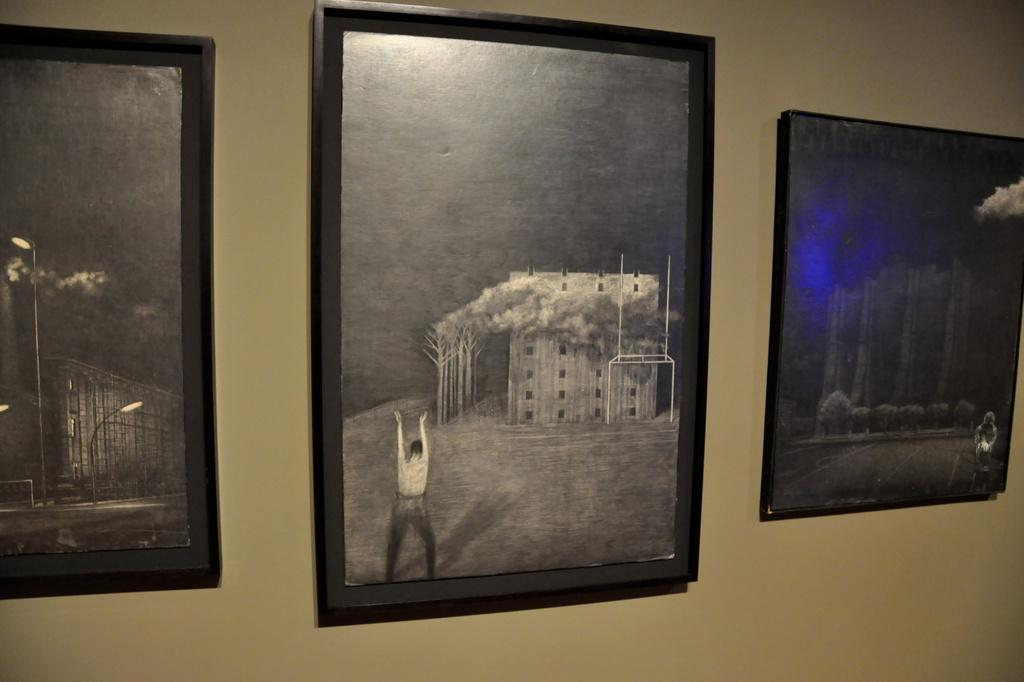What objects can be seen in the image? There are photo frames in the image. Where are the photo frames located? The photo frames are attached to the wall. What type of brush is being used to paint the apple in the image? There is no brush or apple present in the image; it only features photo frames attached to the wall. 